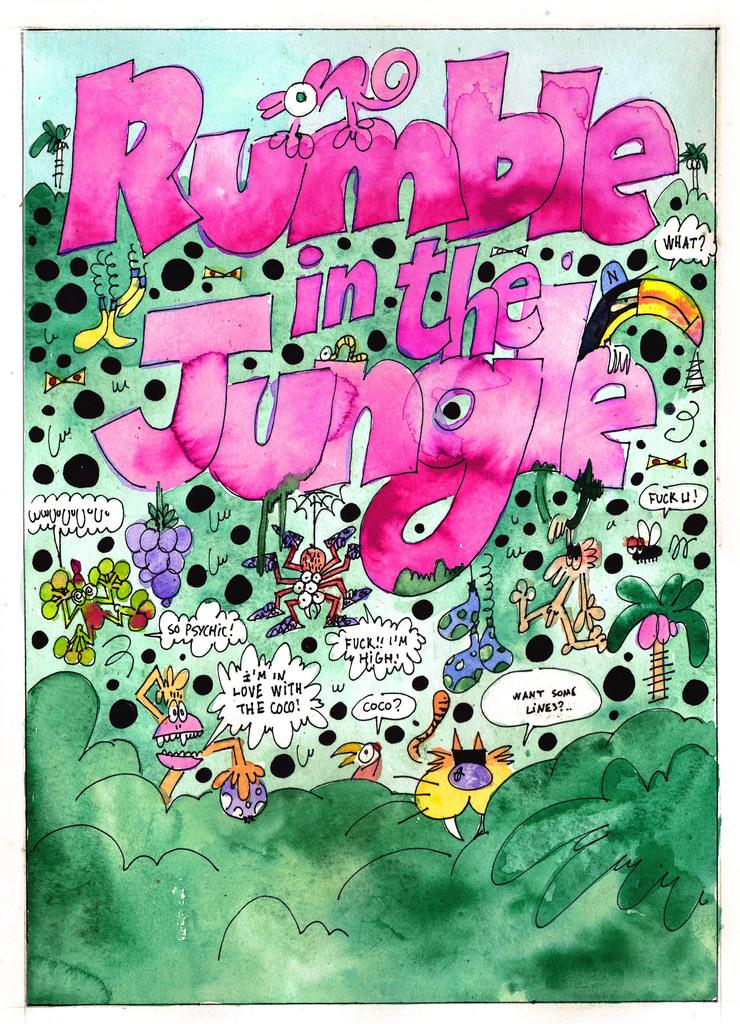What type of images are present in the picture? There are cartoons in the picture. What color is the text in the picture? The text in the picture is pink. What color is the background of the picture? The background of the picture is green. How does the stomach of the cartoon character appear in the image? There is no cartoon character with a visible stomach in the image. 